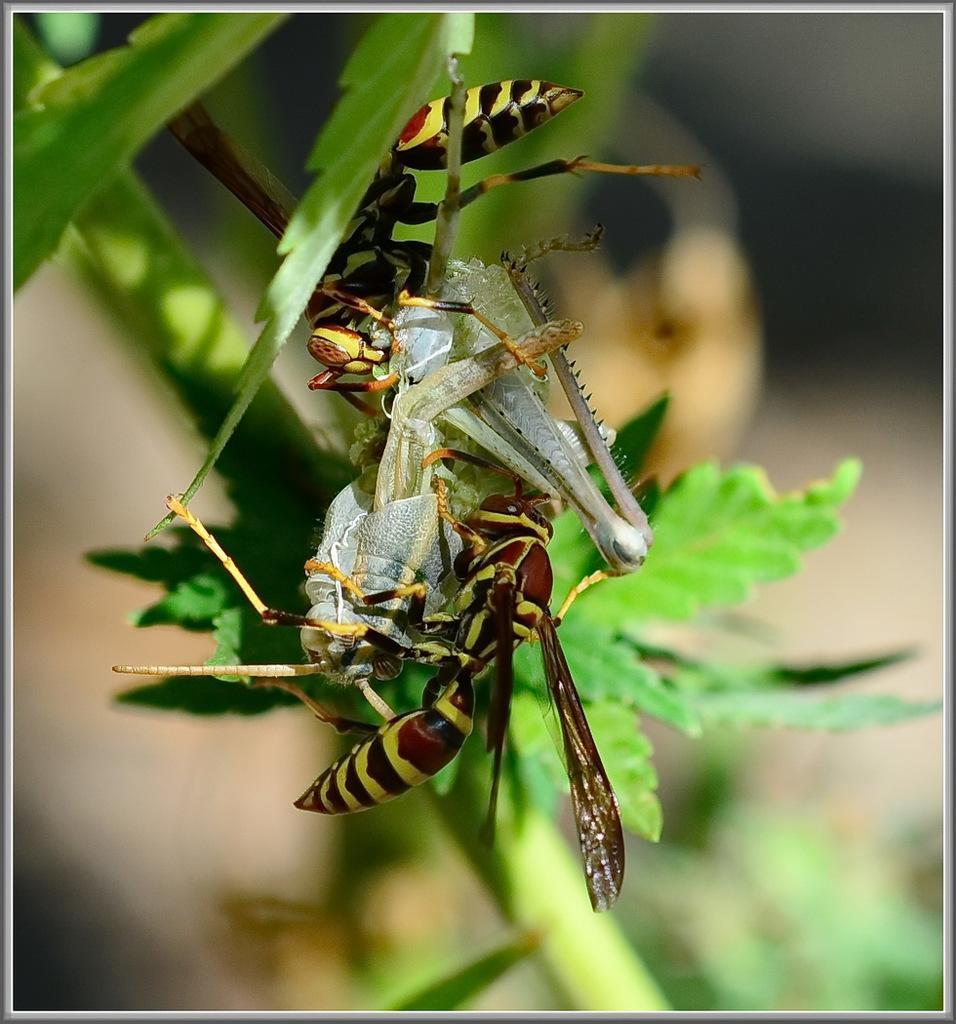Could you give a brief overview of what you see in this image? In this image there are few insects on the plant having few leaves. Background is blurry. 